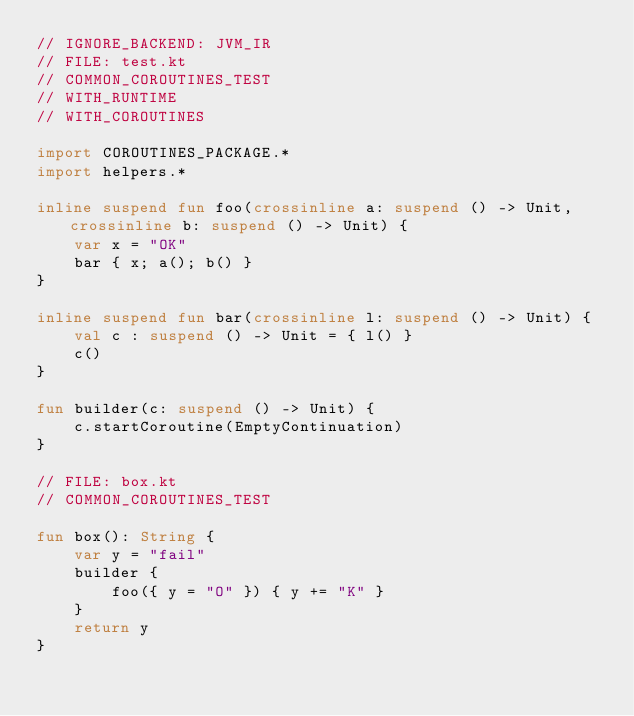<code> <loc_0><loc_0><loc_500><loc_500><_Kotlin_>// IGNORE_BACKEND: JVM_IR
// FILE: test.kt
// COMMON_COROUTINES_TEST
// WITH_RUNTIME
// WITH_COROUTINES

import COROUTINES_PACKAGE.*
import helpers.*

inline suspend fun foo(crossinline a: suspend () -> Unit, crossinline b: suspend () -> Unit) {
    var x = "OK"
    bar { x; a(); b() }
}

inline suspend fun bar(crossinline l: suspend () -> Unit) {
    val c : suspend () -> Unit = { l() }
    c()
}

fun builder(c: suspend () -> Unit) {
    c.startCoroutine(EmptyContinuation)
}

// FILE: box.kt
// COMMON_COROUTINES_TEST

fun box(): String {
    var y = "fail"
    builder {
        foo({ y = "O" }) { y += "K" }
    }
    return y
}</code> 